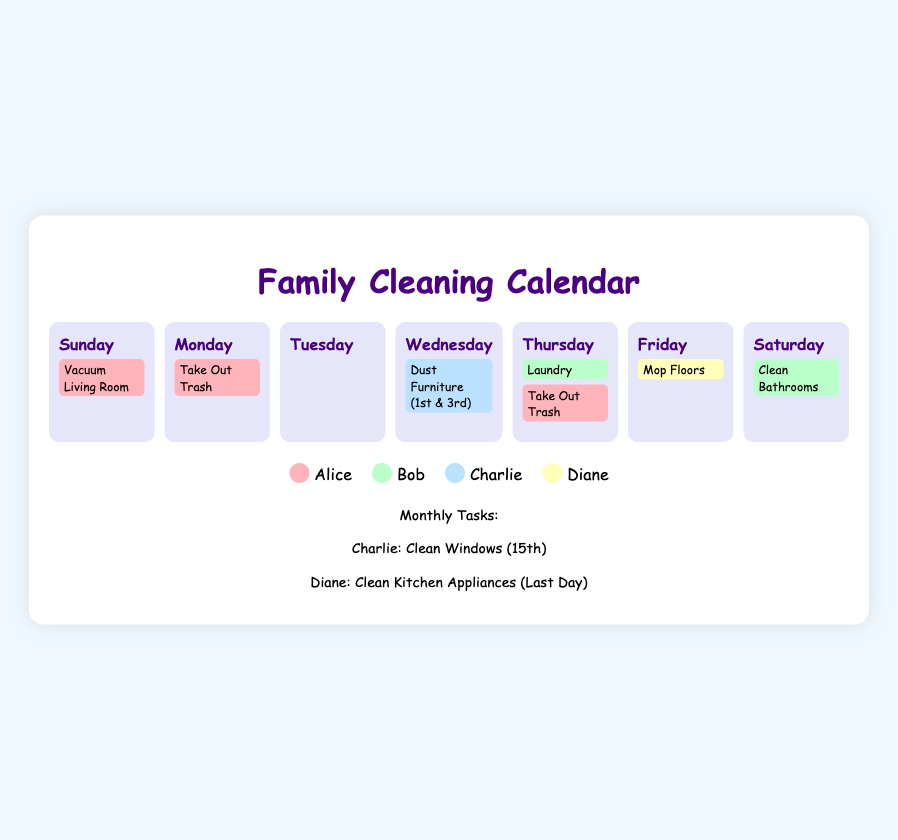What task is assigned to Alice on Sunday? Alice is assigned to "Vacuum Living Room" on Sunday as per the cleaning schedule.
Answer: Vacuum Living Room Which task is assigned to Bob on Saturday? Bob's task for Saturday is to "Clean Bathrooms" according to the calendar.
Answer: Clean Bathrooms On which day does Charlie have a cleaning task? Charlie has a task to "Dust Furniture" on Wednesday, specifically on the 1st and 3rd weeks.
Answer: Wednesday What is the specific date for Charlie's monthly task? Charlie's monthly task is to "Clean Windows" on the 15th as stated in the document.
Answer: 15th Who is responsible for mopping floors on Friday? The document states that Diane is responsible for "Mop Floors" on Friday.
Answer: Diane How many tasks does Alice have scheduled for the week? Alice has two tasks scheduled: "Vacuum Living Room" on Sunday and "Take Out Trash" on Thursday.
Answer: 2 What color represents Diane in the legend? Diane's tasks in the calendar are represented by a light yellow color in the legend section.
Answer: Yellow Which family member is assigned to do laundry? Bob is assigned the task of "Laundry" on Thursday according to the schedule.
Answer: Bob What cleaning task does Diane perform at the end of the month? Diane's cleaning task at the end of the month is to "Clean Kitchen Appliances" as mentioned in the document.
Answer: Clean Kitchen Appliances 